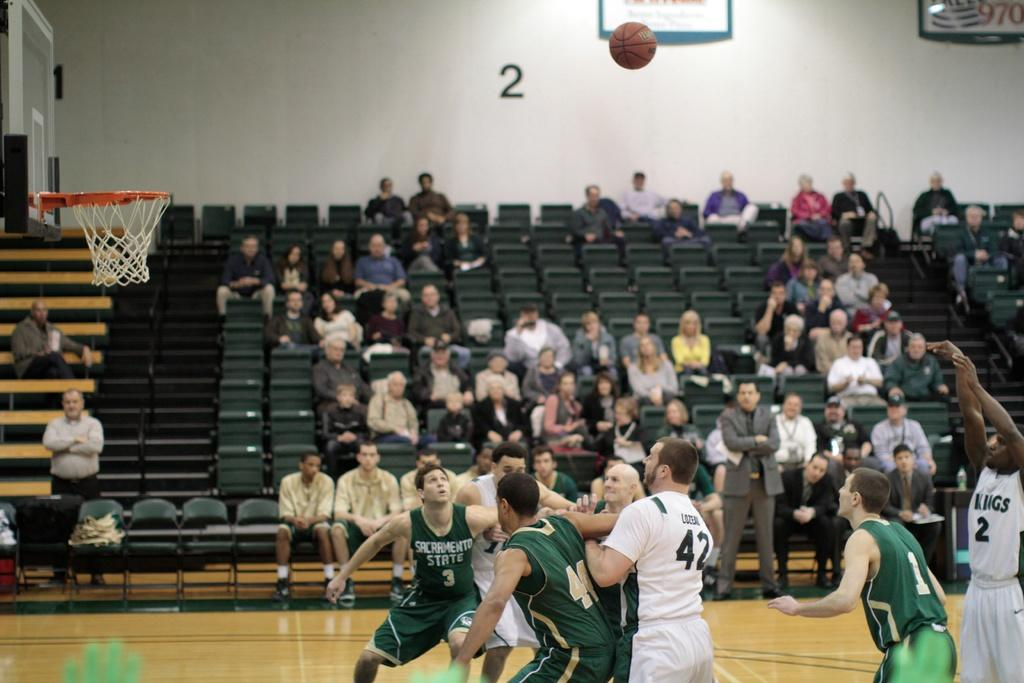What type of sports facility is shown in the image? There is a basketball court in the image. What activity is taking place on the court? Players are playing basketball on the court. Are there any spectators in the image? Yes, people are sitting on the seats and watching the match. What can be found behind the basketball court? There are seats behind the court. What type of plants can be seen growing on the basketball court in the image? There are no plants growing on the basketball court in the image. What kind of cake is being served to the players during the match? There is no cake present in the image; it is a basketball court with players and spectators. 